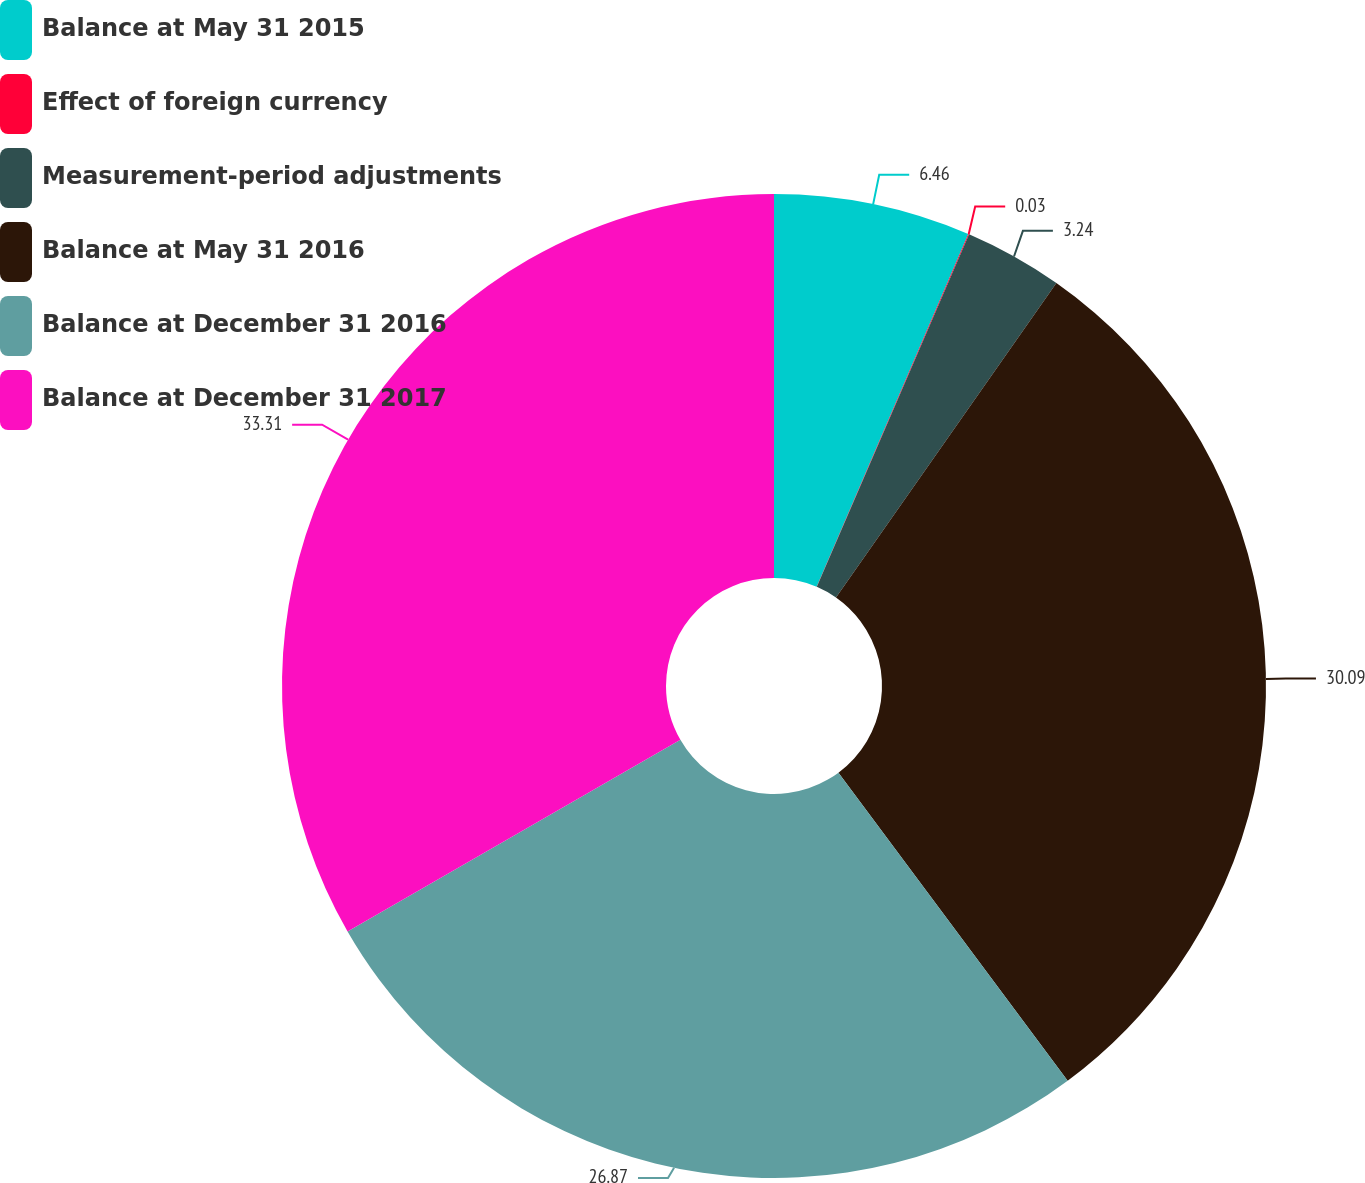<chart> <loc_0><loc_0><loc_500><loc_500><pie_chart><fcel>Balance at May 31 2015<fcel>Effect of foreign currency<fcel>Measurement-period adjustments<fcel>Balance at May 31 2016<fcel>Balance at December 31 2016<fcel>Balance at December 31 2017<nl><fcel>6.46%<fcel>0.03%<fcel>3.24%<fcel>30.09%<fcel>26.87%<fcel>33.31%<nl></chart> 